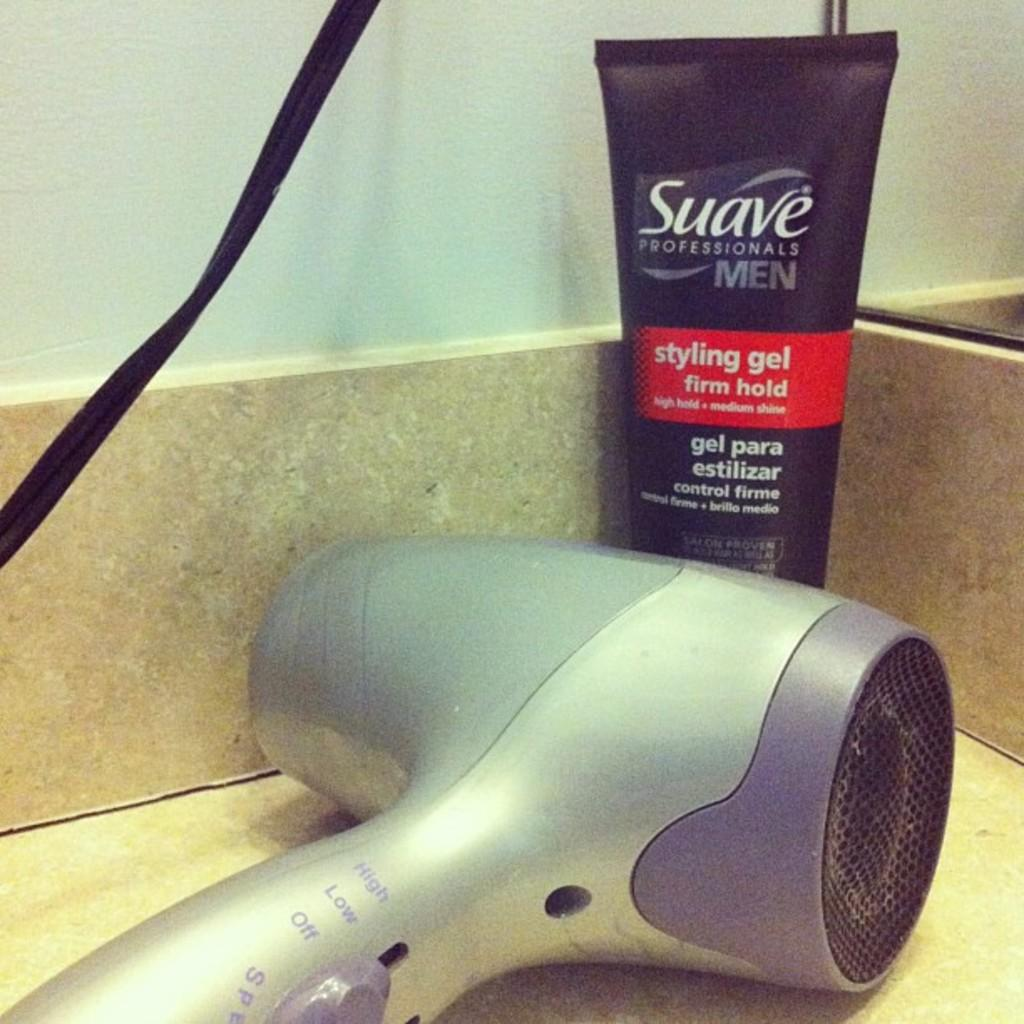What is the main object in the image? There is a hair dryer in the image. What other item can be seen with the hair dryer? There is a gel tube in the image. Where are the hair dryer and gel tube located? Both the hair dryer and gel tube are on a desk. What can be seen in the background of the image? There is a white wall in the background of the image. What type of throat-soothing remedy is present in the image? There is no throat-soothing remedy present in the image; it features a hair dryer and a gel tube on a desk with a white wall in the background. 